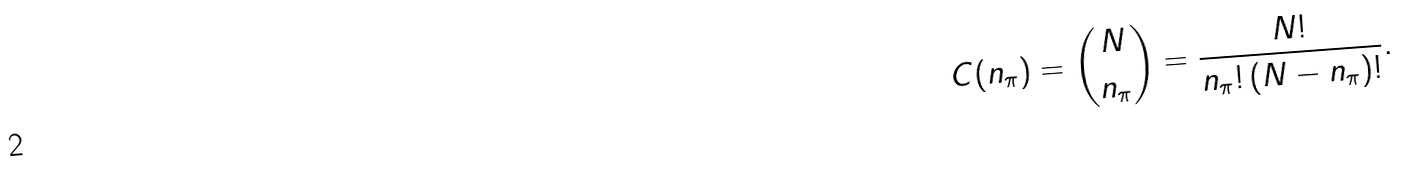Convert formula to latex. <formula><loc_0><loc_0><loc_500><loc_500>C ( n _ { \pi } ) = { N \choose n _ { \pi } } = \frac { N ! } { n _ { \pi } ! \left ( N - n _ { \pi } \right ) ! } .</formula> 